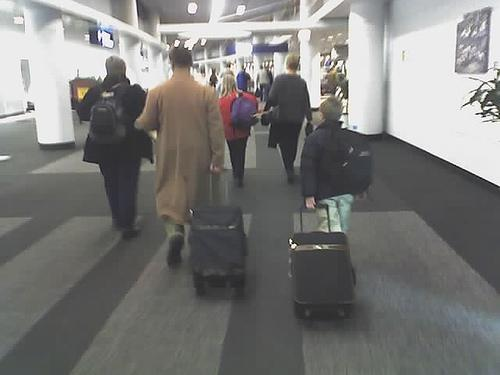Question: what color is the floor?
Choices:
A. Brown.
B. Gray.
C. Black.
D. White.
Answer with the letter. Answer: B Question: how many people are wearing red?
Choices:
A. Two.
B. Four.
C. One.
D. Five.
Answer with the letter. Answer: C Question: where was the photo taken?
Choices:
A. At a train station.
B. At a subway station.
C. At a bus station.
D. At an airport.
Answer with the letter. Answer: D Question: what are the two people closest to the camera pulling?
Choices:
A. Carts.
B. Bags.
C. Suitcases.
D. Chairs.
Answer with the letter. Answer: C Question: where are the pictures?
Choices:
A. Wall.
B. Table.
C. Counter.
D. Piano.
Answer with the letter. Answer: A Question: what color shirt is the blonde wearing?
Choices:
A. Red.
B. Green.
C. Pink.
D. Yellow.
Answer with the letter. Answer: A 